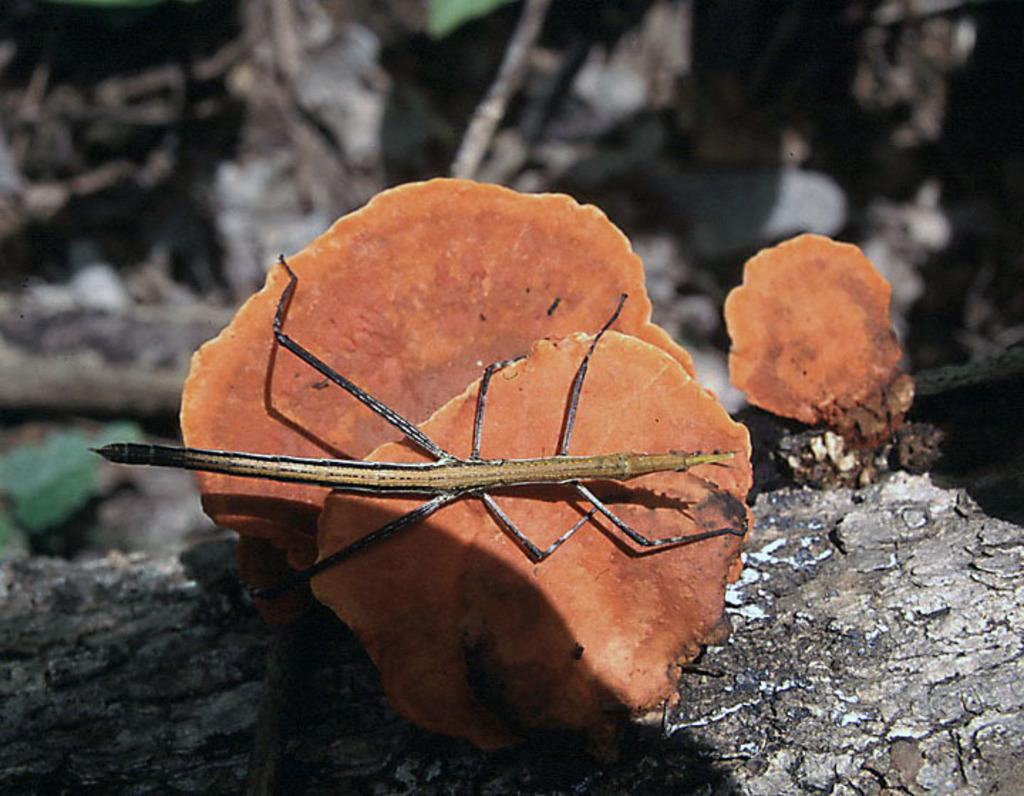What type of insect is in the image? There is a grasshopper in the image. What is the grasshopper resting on? The grasshopper is on a mushroom. Where is the throne located in the image? There is no throne present in the image. What type of insect is crawling on the beetle in the image? There is no beetle present in the image, and therefore no insect crawling on it. 